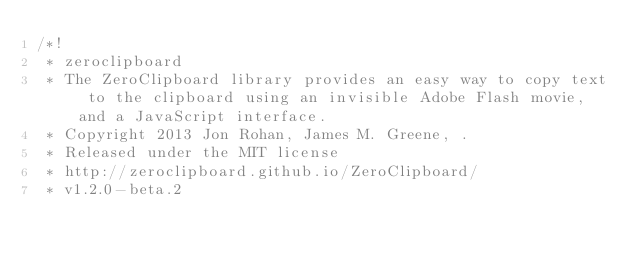<code> <loc_0><loc_0><loc_500><loc_500><_JavaScript_>/*!
 * zeroclipboard
 * The ZeroClipboard library provides an easy way to copy text to the clipboard using an invisible Adobe Flash movie, and a JavaScript interface.
 * Copyright 2013 Jon Rohan, James M. Greene, .
 * Released under the MIT license
 * http://zeroclipboard.github.io/ZeroClipboard/
 * v1.2.0-beta.2</code> 